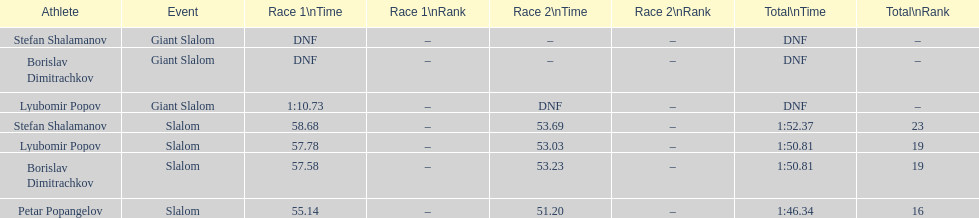Which athletes had consecutive times under 58 for both races? Lyubomir Popov, Borislav Dimitrachkov, Petar Popangelov. 